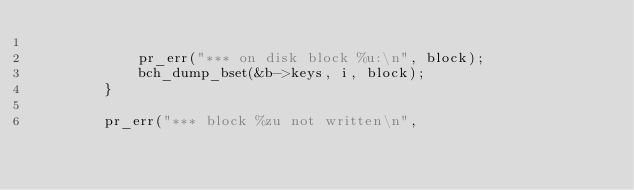<code> <loc_0><loc_0><loc_500><loc_500><_C_>
			pr_err("*** on disk block %u:\n", block);
			bch_dump_bset(&b->keys, i, block);
		}

		pr_err("*** block %zu not written\n",</code> 